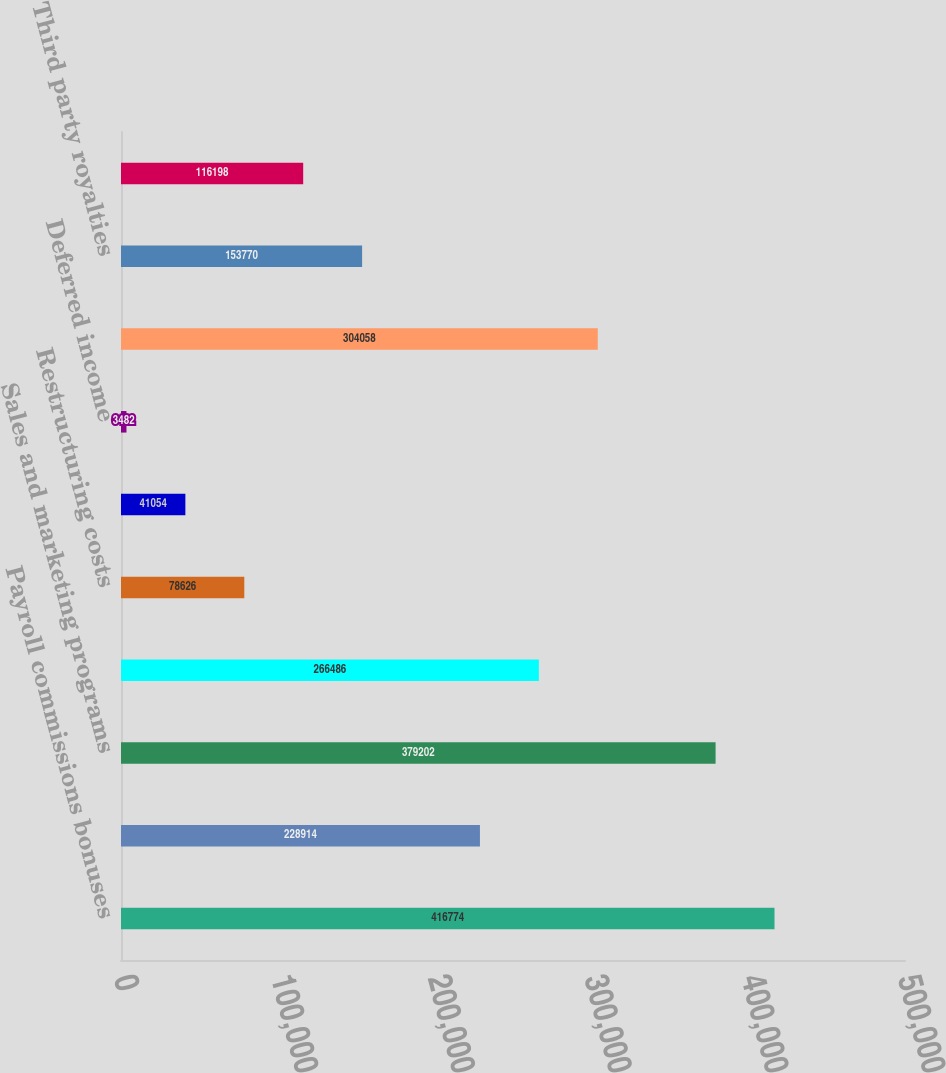Convert chart. <chart><loc_0><loc_0><loc_500><loc_500><bar_chart><fcel>Payroll commissions bonuses<fcel>General insurance<fcel>Sales and marketing programs<fcel>Professional and legal costs<fcel>Restructuring costs<fcel>Warranty liabilities<fcel>Deferred income<fcel>Accrued vacation and holidays<fcel>Third party royalties<fcel>Current portion of derivatives<nl><fcel>416774<fcel>228914<fcel>379202<fcel>266486<fcel>78626<fcel>41054<fcel>3482<fcel>304058<fcel>153770<fcel>116198<nl></chart> 